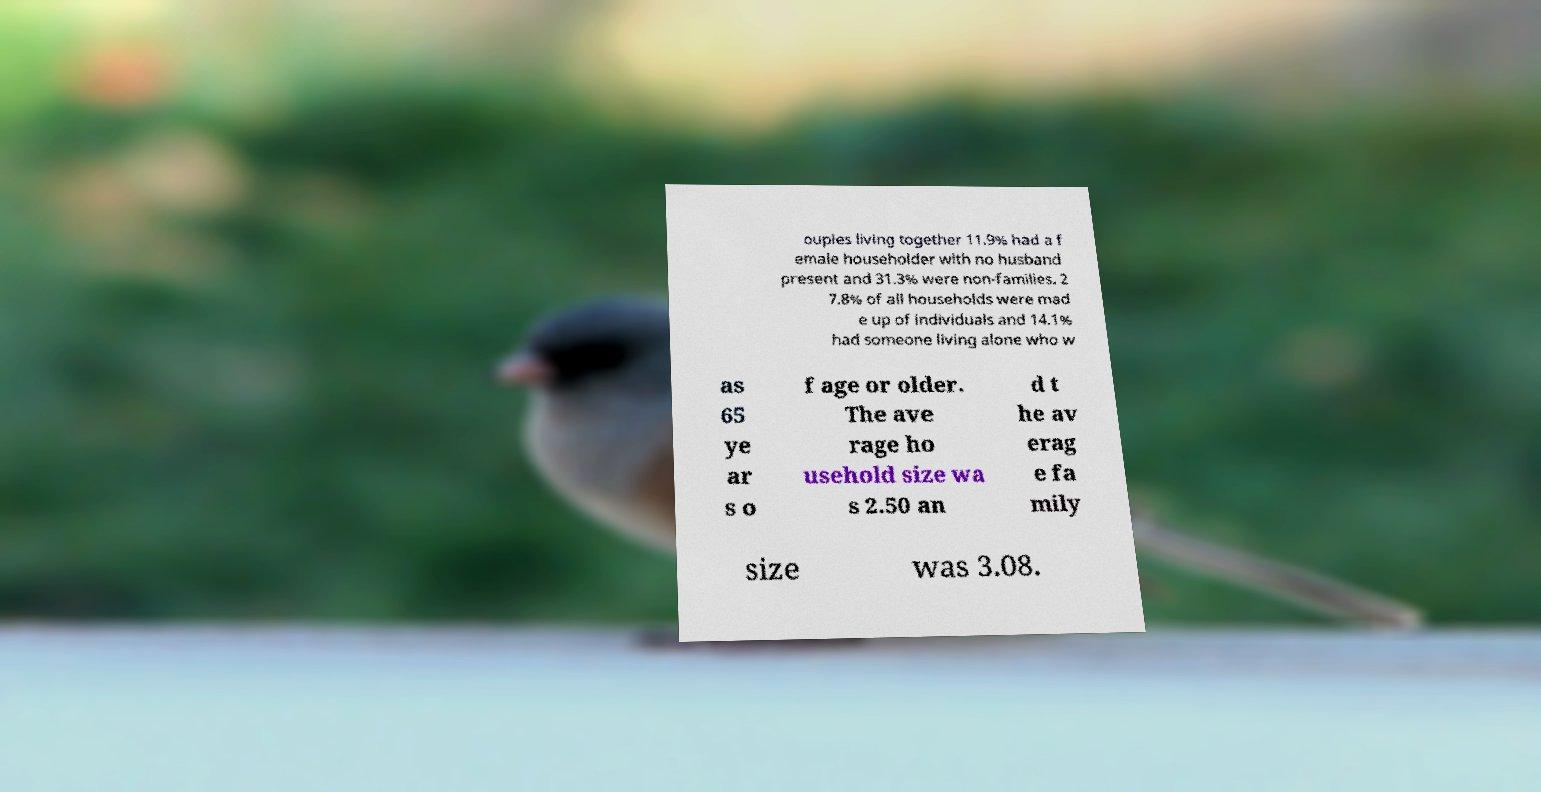Please read and relay the text visible in this image. What does it say? ouples living together 11.9% had a f emale householder with no husband present and 31.3% were non-families. 2 7.8% of all households were mad e up of individuals and 14.1% had someone living alone who w as 65 ye ar s o f age or older. The ave rage ho usehold size wa s 2.50 an d t he av erag e fa mily size was 3.08. 